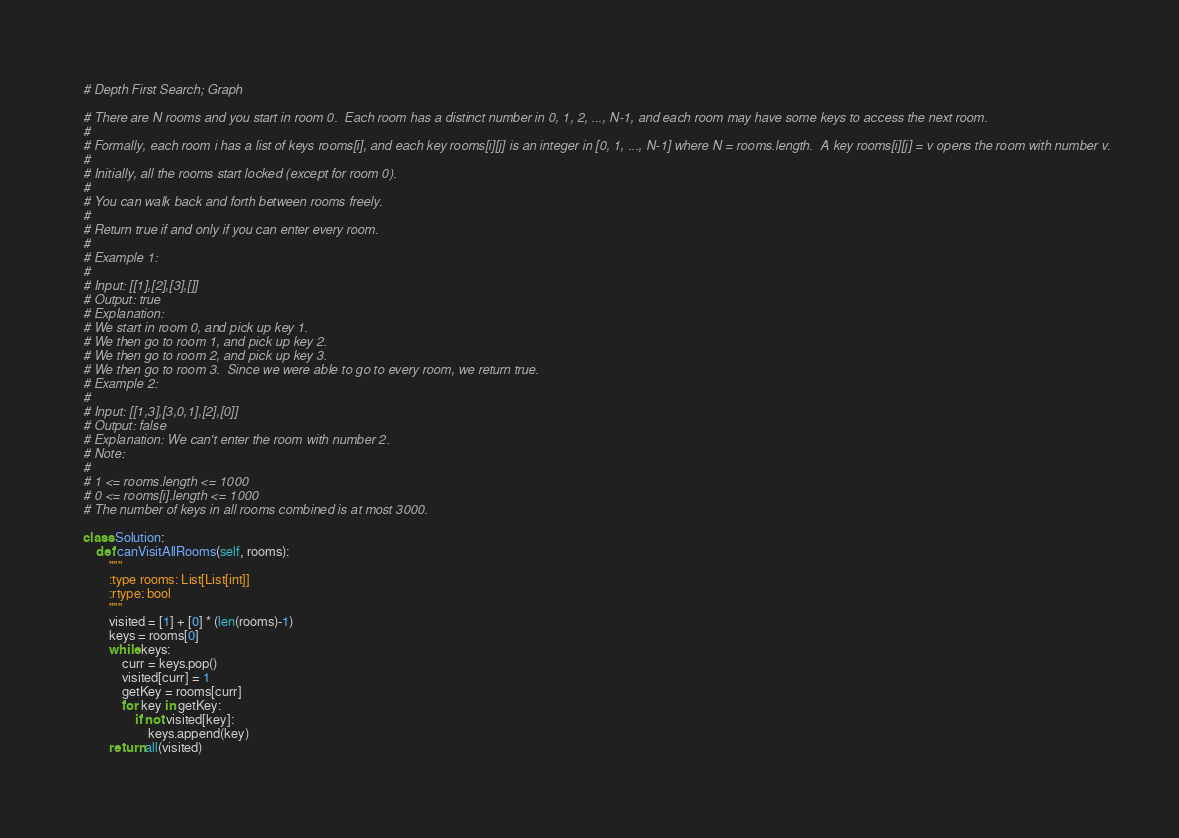Convert code to text. <code><loc_0><loc_0><loc_500><loc_500><_Python_># Depth First Search; Graph

# There are N rooms and you start in room 0.  Each room has a distinct number in 0, 1, 2, ..., N-1, and each room may have some keys to access the next room.
#
# Formally, each room i has a list of keys rooms[i], and each key rooms[i][j] is an integer in [0, 1, ..., N-1] where N = rooms.length.  A key rooms[i][j] = v opens the room with number v.
#
# Initially, all the rooms start locked (except for room 0).
#
# You can walk back and forth between rooms freely.
#
# Return true if and only if you can enter every room.
#
# Example 1:
#
# Input: [[1],[2],[3],[]]
# Output: true
# Explanation:
# We start in room 0, and pick up key 1.
# We then go to room 1, and pick up key 2.
# We then go to room 2, and pick up key 3.
# We then go to room 3.  Since we were able to go to every room, we return true.
# Example 2:
#
# Input: [[1,3],[3,0,1],[2],[0]]
# Output: false
# Explanation: We can't enter the room with number 2.
# Note:
#
# 1 <= rooms.length <= 1000
# 0 <= rooms[i].length <= 1000
# The number of keys in all rooms combined is at most 3000.

class Solution:
    def canVisitAllRooms(self, rooms):
        """
        :type rooms: List[List[int]]
        :rtype: bool
        """
        visited = [1] + [0] * (len(rooms)-1)
        keys = rooms[0]
        while keys:
            curr = keys.pop()
            visited[curr] = 1
            getKey = rooms[curr]
            for key in getKey:
                if not visited[key]:
                    keys.append(key)
        return all(visited)
</code> 